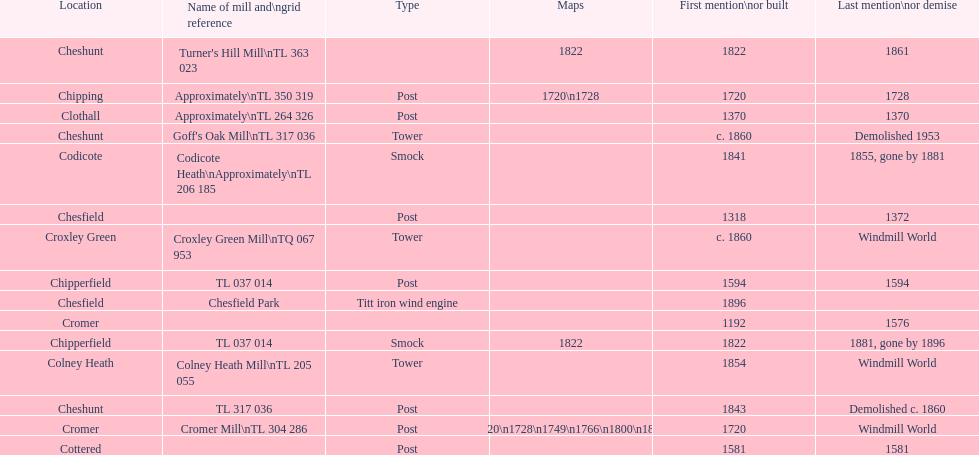What is the name of the only "c" mill located in colney health? Colney Heath Mill. Could you help me parse every detail presented in this table? {'header': ['Location', 'Name of mill and\\ngrid reference', 'Type', 'Maps', 'First mention\\nor built', 'Last mention\\nor demise'], 'rows': [['Cheshunt', "Turner's Hill Mill\\nTL 363 023", '', '1822', '1822', '1861'], ['Chipping', 'Approximately\\nTL 350 319', 'Post', '1720\\n1728', '1720', '1728'], ['Clothall', 'Approximately\\nTL 264 326', 'Post', '', '1370', '1370'], ['Cheshunt', "Goff's Oak Mill\\nTL 317 036", 'Tower', '', 'c. 1860', 'Demolished 1953'], ['Codicote', 'Codicote Heath\\nApproximately\\nTL 206 185', 'Smock', '', '1841', '1855, gone by 1881'], ['Chesfield', '', 'Post', '', '1318', '1372'], ['Croxley Green', 'Croxley Green Mill\\nTQ 067 953', 'Tower', '', 'c. 1860', 'Windmill World'], ['Chipperfield', 'TL 037 014', 'Post', '', '1594', '1594'], ['Chesfield', 'Chesfield Park', 'Titt iron wind engine', '', '1896', ''], ['Cromer', '', '', '', '1192', '1576'], ['Chipperfield', 'TL 037 014', 'Smock', '1822', '1822', '1881, gone by 1896'], ['Colney Heath', 'Colney Heath Mill\\nTL 205 055', 'Tower', '', '1854', 'Windmill World'], ['Cheshunt', 'TL 317 036', 'Post', '', '1843', 'Demolished c. 1860'], ['Cromer', 'Cromer Mill\\nTL 304 286', 'Post', '1720\\n1728\\n1749\\n1766\\n1800\\n1822', '1720', 'Windmill World'], ['Cottered', '', 'Post', '', '1581', '1581']]} 